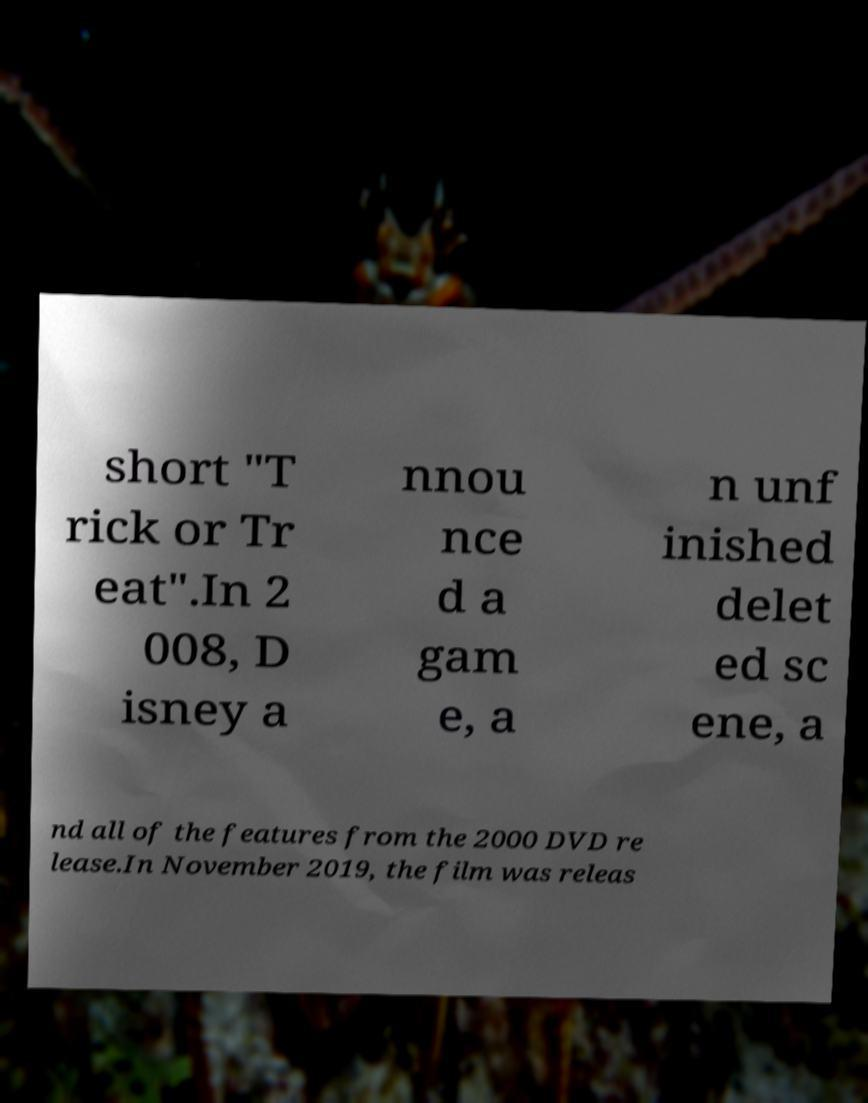Can you read and provide the text displayed in the image?This photo seems to have some interesting text. Can you extract and type it out for me? short "T rick or Tr eat".In 2 008, D isney a nnou nce d a gam e, a n unf inished delet ed sc ene, a nd all of the features from the 2000 DVD re lease.In November 2019, the film was releas 